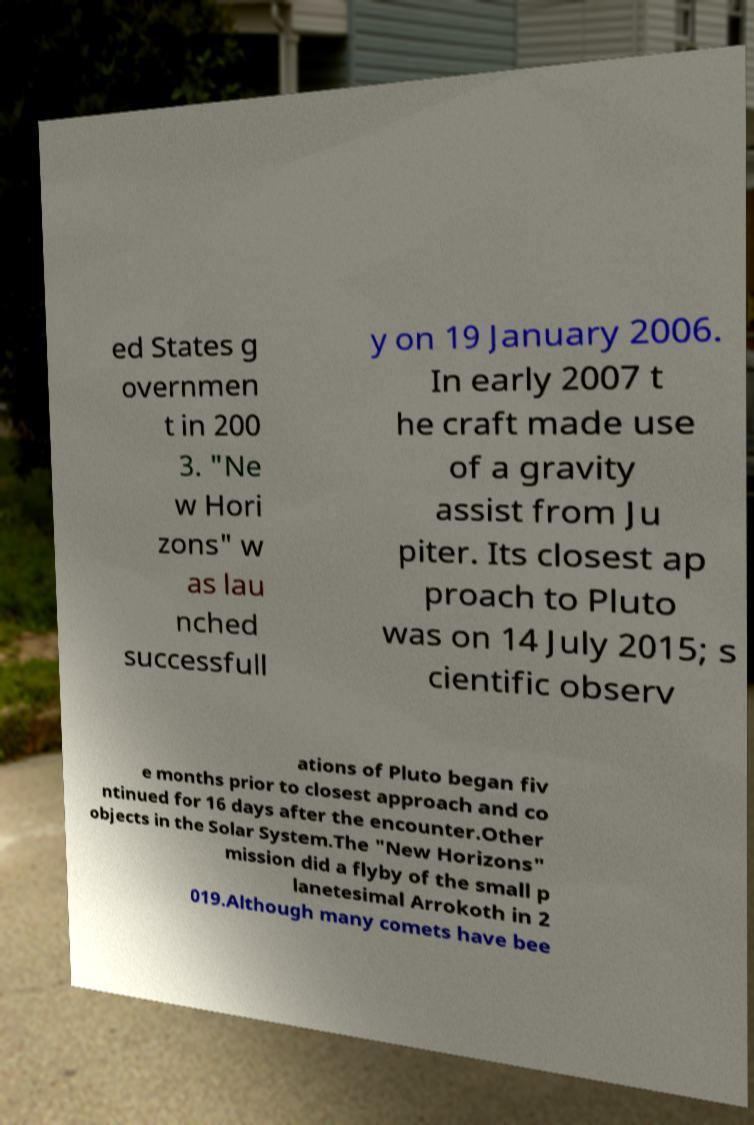There's text embedded in this image that I need extracted. Can you transcribe it verbatim? ed States g overnmen t in 200 3. "Ne w Hori zons" w as lau nched successfull y on 19 January 2006. In early 2007 t he craft made use of a gravity assist from Ju piter. Its closest ap proach to Pluto was on 14 July 2015; s cientific observ ations of Pluto began fiv e months prior to closest approach and co ntinued for 16 days after the encounter.Other objects in the Solar System.The "New Horizons" mission did a flyby of the small p lanetesimal Arrokoth in 2 019.Although many comets have bee 